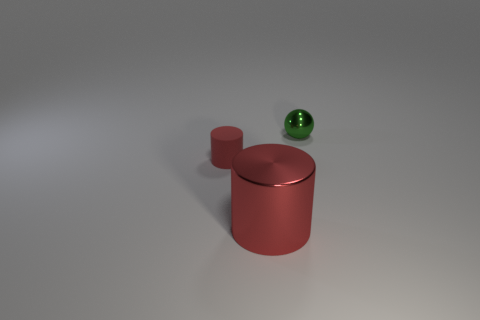Add 3 green metallic balls. How many objects exist? 6 Subtract all cylinders. How many objects are left? 1 Subtract 1 cylinders. How many cylinders are left? 1 Add 3 small cylinders. How many small cylinders are left? 4 Add 3 spheres. How many spheres exist? 4 Subtract 0 yellow balls. How many objects are left? 3 Subtract all blue balls. Subtract all brown blocks. How many balls are left? 1 Subtract all purple cylinders. How many cyan balls are left? 0 Subtract all tiny matte objects. Subtract all red things. How many objects are left? 0 